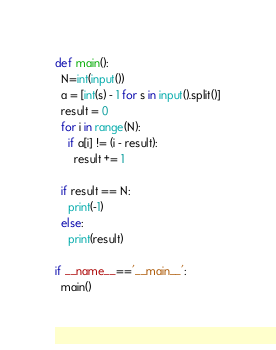<code> <loc_0><loc_0><loc_500><loc_500><_Python_>def main():
  N=int(input())
  a = [int(s) - 1 for s in input().split()]
  result = 0
  for i in range(N):
    if a[i] != (i - result):
      result += 1

  if result == N:
    print(-1)
  else:
    print(result)  

if __name__=='__main__':
  main()</code> 